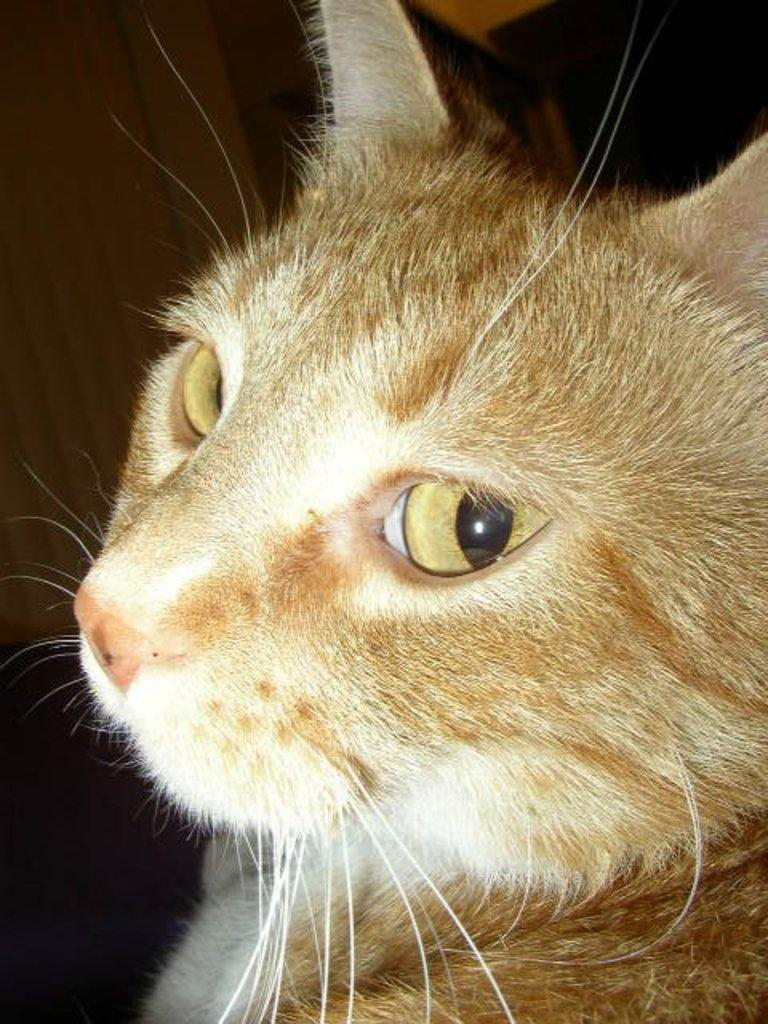What type of animal is present in the image? There is a cat in the image. Is the cat riding a skate in the image? There is no skate present in the image, and the cat is not depicted as riding anything. 